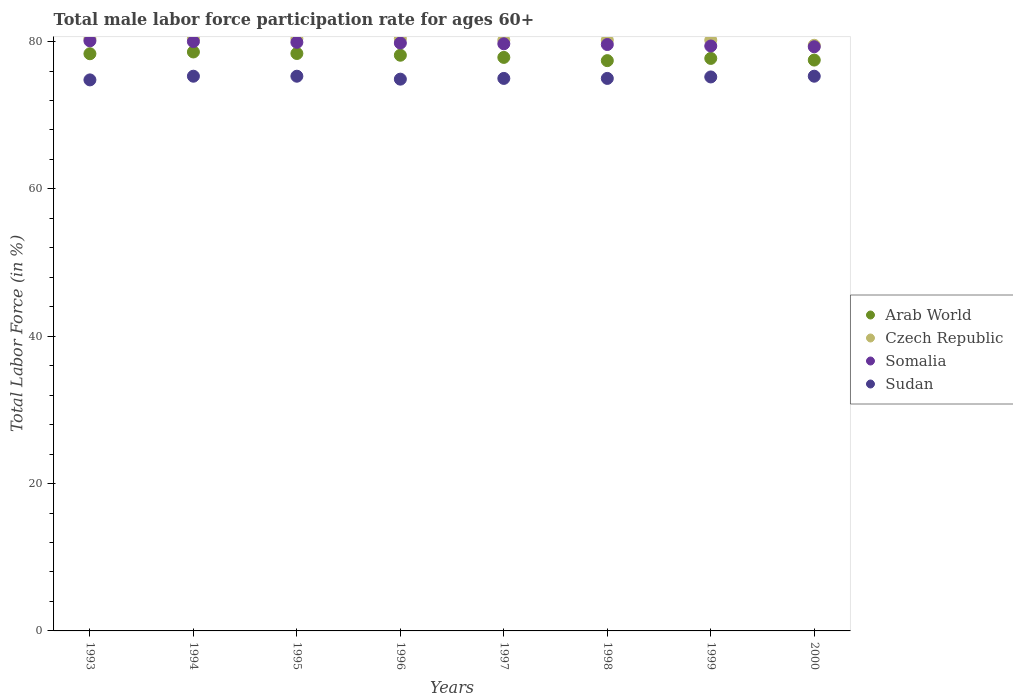How many different coloured dotlines are there?
Provide a short and direct response. 4. Is the number of dotlines equal to the number of legend labels?
Your answer should be very brief. Yes. What is the male labor force participation rate in Sudan in 2000?
Your answer should be compact. 75.3. Across all years, what is the maximum male labor force participation rate in Arab World?
Offer a terse response. 78.59. Across all years, what is the minimum male labor force participation rate in Arab World?
Provide a short and direct response. 77.41. In which year was the male labor force participation rate in Arab World maximum?
Keep it short and to the point. 1994. In which year was the male labor force participation rate in Sudan minimum?
Give a very brief answer. 1993. What is the total male labor force participation rate in Czech Republic in the graph?
Your response must be concise. 641.7. What is the difference between the male labor force participation rate in Czech Republic in 1994 and that in 1998?
Provide a short and direct response. 0.2. What is the difference between the male labor force participation rate in Somalia in 1994 and the male labor force participation rate in Czech Republic in 1996?
Your answer should be very brief. -0.4. What is the average male labor force participation rate in Czech Republic per year?
Provide a succinct answer. 80.21. In the year 1997, what is the difference between the male labor force participation rate in Czech Republic and male labor force participation rate in Somalia?
Your response must be concise. 0.5. What is the ratio of the male labor force participation rate in Sudan in 1993 to that in 1999?
Ensure brevity in your answer.  0.99. What is the difference between the highest and the lowest male labor force participation rate in Arab World?
Provide a short and direct response. 1.18. Is the sum of the male labor force participation rate in Czech Republic in 1994 and 1999 greater than the maximum male labor force participation rate in Arab World across all years?
Ensure brevity in your answer.  Yes. Is it the case that in every year, the sum of the male labor force participation rate in Somalia and male labor force participation rate in Sudan  is greater than the male labor force participation rate in Arab World?
Your answer should be very brief. Yes. Is the male labor force participation rate in Czech Republic strictly greater than the male labor force participation rate in Arab World over the years?
Offer a terse response. Yes. Is the male labor force participation rate in Arab World strictly less than the male labor force participation rate in Sudan over the years?
Keep it short and to the point. No. How many dotlines are there?
Give a very brief answer. 4. Where does the legend appear in the graph?
Your answer should be compact. Center right. What is the title of the graph?
Make the answer very short. Total male labor force participation rate for ages 60+. Does "India" appear as one of the legend labels in the graph?
Give a very brief answer. No. What is the label or title of the Y-axis?
Your answer should be very brief. Total Labor Force (in %). What is the Total Labor Force (in %) in Arab World in 1993?
Make the answer very short. 78.35. What is the Total Labor Force (in %) of Czech Republic in 1993?
Make the answer very short. 80.4. What is the Total Labor Force (in %) in Somalia in 1993?
Make the answer very short. 80.1. What is the Total Labor Force (in %) in Sudan in 1993?
Make the answer very short. 74.8. What is the Total Labor Force (in %) in Arab World in 1994?
Make the answer very short. 78.59. What is the Total Labor Force (in %) in Czech Republic in 1994?
Your answer should be very brief. 80.4. What is the Total Labor Force (in %) of Sudan in 1994?
Ensure brevity in your answer.  75.3. What is the Total Labor Force (in %) of Arab World in 1995?
Keep it short and to the point. 78.38. What is the Total Labor Force (in %) in Czech Republic in 1995?
Make the answer very short. 80.4. What is the Total Labor Force (in %) of Somalia in 1995?
Offer a very short reply. 79.9. What is the Total Labor Force (in %) of Sudan in 1995?
Ensure brevity in your answer.  75.3. What is the Total Labor Force (in %) in Arab World in 1996?
Make the answer very short. 78.15. What is the Total Labor Force (in %) of Czech Republic in 1996?
Provide a short and direct response. 80.4. What is the Total Labor Force (in %) in Somalia in 1996?
Your answer should be compact. 79.8. What is the Total Labor Force (in %) of Sudan in 1996?
Ensure brevity in your answer.  74.9. What is the Total Labor Force (in %) in Arab World in 1997?
Ensure brevity in your answer.  77.85. What is the Total Labor Force (in %) of Czech Republic in 1997?
Your answer should be compact. 80.2. What is the Total Labor Force (in %) of Somalia in 1997?
Your response must be concise. 79.7. What is the Total Labor Force (in %) of Sudan in 1997?
Your answer should be very brief. 75. What is the Total Labor Force (in %) in Arab World in 1998?
Ensure brevity in your answer.  77.41. What is the Total Labor Force (in %) of Czech Republic in 1998?
Offer a very short reply. 80.2. What is the Total Labor Force (in %) of Somalia in 1998?
Your answer should be very brief. 79.6. What is the Total Labor Force (in %) in Sudan in 1998?
Your answer should be compact. 75. What is the Total Labor Force (in %) of Arab World in 1999?
Give a very brief answer. 77.72. What is the Total Labor Force (in %) of Czech Republic in 1999?
Provide a short and direct response. 80.2. What is the Total Labor Force (in %) in Somalia in 1999?
Make the answer very short. 79.4. What is the Total Labor Force (in %) of Sudan in 1999?
Your answer should be compact. 75.2. What is the Total Labor Force (in %) in Arab World in 2000?
Make the answer very short. 77.49. What is the Total Labor Force (in %) of Czech Republic in 2000?
Offer a very short reply. 79.5. What is the Total Labor Force (in %) in Somalia in 2000?
Offer a very short reply. 79.3. What is the Total Labor Force (in %) in Sudan in 2000?
Your response must be concise. 75.3. Across all years, what is the maximum Total Labor Force (in %) in Arab World?
Offer a very short reply. 78.59. Across all years, what is the maximum Total Labor Force (in %) in Czech Republic?
Offer a terse response. 80.4. Across all years, what is the maximum Total Labor Force (in %) in Somalia?
Make the answer very short. 80.1. Across all years, what is the maximum Total Labor Force (in %) in Sudan?
Keep it short and to the point. 75.3. Across all years, what is the minimum Total Labor Force (in %) of Arab World?
Your answer should be compact. 77.41. Across all years, what is the minimum Total Labor Force (in %) of Czech Republic?
Provide a short and direct response. 79.5. Across all years, what is the minimum Total Labor Force (in %) in Somalia?
Your answer should be compact. 79.3. Across all years, what is the minimum Total Labor Force (in %) of Sudan?
Make the answer very short. 74.8. What is the total Total Labor Force (in %) of Arab World in the graph?
Give a very brief answer. 623.94. What is the total Total Labor Force (in %) in Czech Republic in the graph?
Provide a succinct answer. 641.7. What is the total Total Labor Force (in %) of Somalia in the graph?
Provide a short and direct response. 637.8. What is the total Total Labor Force (in %) of Sudan in the graph?
Keep it short and to the point. 600.8. What is the difference between the Total Labor Force (in %) of Arab World in 1993 and that in 1994?
Ensure brevity in your answer.  -0.24. What is the difference between the Total Labor Force (in %) of Czech Republic in 1993 and that in 1994?
Offer a terse response. 0. What is the difference between the Total Labor Force (in %) in Somalia in 1993 and that in 1994?
Keep it short and to the point. 0.1. What is the difference between the Total Labor Force (in %) in Arab World in 1993 and that in 1995?
Provide a succinct answer. -0.03. What is the difference between the Total Labor Force (in %) in Czech Republic in 1993 and that in 1995?
Ensure brevity in your answer.  0. What is the difference between the Total Labor Force (in %) of Arab World in 1993 and that in 1996?
Give a very brief answer. 0.2. What is the difference between the Total Labor Force (in %) in Somalia in 1993 and that in 1996?
Provide a short and direct response. 0.3. What is the difference between the Total Labor Force (in %) in Sudan in 1993 and that in 1996?
Your answer should be compact. -0.1. What is the difference between the Total Labor Force (in %) of Arab World in 1993 and that in 1997?
Give a very brief answer. 0.5. What is the difference between the Total Labor Force (in %) in Sudan in 1993 and that in 1997?
Your answer should be compact. -0.2. What is the difference between the Total Labor Force (in %) in Arab World in 1993 and that in 1998?
Keep it short and to the point. 0.94. What is the difference between the Total Labor Force (in %) in Somalia in 1993 and that in 1998?
Your answer should be compact. 0.5. What is the difference between the Total Labor Force (in %) in Arab World in 1993 and that in 1999?
Your response must be concise. 0.63. What is the difference between the Total Labor Force (in %) in Czech Republic in 1993 and that in 1999?
Your answer should be very brief. 0.2. What is the difference between the Total Labor Force (in %) of Sudan in 1993 and that in 1999?
Ensure brevity in your answer.  -0.4. What is the difference between the Total Labor Force (in %) in Arab World in 1993 and that in 2000?
Ensure brevity in your answer.  0.86. What is the difference between the Total Labor Force (in %) of Czech Republic in 1993 and that in 2000?
Offer a terse response. 0.9. What is the difference between the Total Labor Force (in %) in Arab World in 1994 and that in 1995?
Keep it short and to the point. 0.21. What is the difference between the Total Labor Force (in %) in Sudan in 1994 and that in 1995?
Make the answer very short. 0. What is the difference between the Total Labor Force (in %) of Arab World in 1994 and that in 1996?
Give a very brief answer. 0.44. What is the difference between the Total Labor Force (in %) in Czech Republic in 1994 and that in 1996?
Your answer should be compact. 0. What is the difference between the Total Labor Force (in %) in Arab World in 1994 and that in 1997?
Ensure brevity in your answer.  0.74. What is the difference between the Total Labor Force (in %) of Czech Republic in 1994 and that in 1997?
Give a very brief answer. 0.2. What is the difference between the Total Labor Force (in %) in Somalia in 1994 and that in 1997?
Make the answer very short. 0.3. What is the difference between the Total Labor Force (in %) in Sudan in 1994 and that in 1997?
Your response must be concise. 0.3. What is the difference between the Total Labor Force (in %) in Arab World in 1994 and that in 1998?
Offer a very short reply. 1.18. What is the difference between the Total Labor Force (in %) in Sudan in 1994 and that in 1999?
Offer a terse response. 0.1. What is the difference between the Total Labor Force (in %) in Arab World in 1994 and that in 2000?
Your response must be concise. 1.1. What is the difference between the Total Labor Force (in %) in Somalia in 1994 and that in 2000?
Your answer should be very brief. 0.7. What is the difference between the Total Labor Force (in %) in Arab World in 1995 and that in 1996?
Your answer should be compact. 0.24. What is the difference between the Total Labor Force (in %) of Czech Republic in 1995 and that in 1996?
Provide a succinct answer. 0. What is the difference between the Total Labor Force (in %) of Somalia in 1995 and that in 1996?
Offer a terse response. 0.1. What is the difference between the Total Labor Force (in %) in Arab World in 1995 and that in 1997?
Provide a short and direct response. 0.53. What is the difference between the Total Labor Force (in %) in Czech Republic in 1995 and that in 1997?
Offer a terse response. 0.2. What is the difference between the Total Labor Force (in %) of Sudan in 1995 and that in 1997?
Your answer should be very brief. 0.3. What is the difference between the Total Labor Force (in %) of Arab World in 1995 and that in 1998?
Your answer should be very brief. 0.97. What is the difference between the Total Labor Force (in %) in Arab World in 1995 and that in 1999?
Provide a short and direct response. 0.67. What is the difference between the Total Labor Force (in %) in Arab World in 1995 and that in 2000?
Keep it short and to the point. 0.89. What is the difference between the Total Labor Force (in %) of Somalia in 1995 and that in 2000?
Give a very brief answer. 0.6. What is the difference between the Total Labor Force (in %) of Arab World in 1996 and that in 1997?
Offer a terse response. 0.3. What is the difference between the Total Labor Force (in %) in Czech Republic in 1996 and that in 1997?
Your answer should be very brief. 0.2. What is the difference between the Total Labor Force (in %) of Somalia in 1996 and that in 1997?
Your answer should be compact. 0.1. What is the difference between the Total Labor Force (in %) in Sudan in 1996 and that in 1997?
Keep it short and to the point. -0.1. What is the difference between the Total Labor Force (in %) in Arab World in 1996 and that in 1998?
Your answer should be compact. 0.73. What is the difference between the Total Labor Force (in %) in Czech Republic in 1996 and that in 1998?
Ensure brevity in your answer.  0.2. What is the difference between the Total Labor Force (in %) in Sudan in 1996 and that in 1998?
Your response must be concise. -0.1. What is the difference between the Total Labor Force (in %) of Arab World in 1996 and that in 1999?
Keep it short and to the point. 0.43. What is the difference between the Total Labor Force (in %) of Somalia in 1996 and that in 1999?
Make the answer very short. 0.4. What is the difference between the Total Labor Force (in %) of Sudan in 1996 and that in 1999?
Give a very brief answer. -0.3. What is the difference between the Total Labor Force (in %) in Arab World in 1996 and that in 2000?
Make the answer very short. 0.66. What is the difference between the Total Labor Force (in %) in Arab World in 1997 and that in 1998?
Your response must be concise. 0.44. What is the difference between the Total Labor Force (in %) in Somalia in 1997 and that in 1998?
Provide a short and direct response. 0.1. What is the difference between the Total Labor Force (in %) in Sudan in 1997 and that in 1998?
Provide a succinct answer. 0. What is the difference between the Total Labor Force (in %) in Arab World in 1997 and that in 1999?
Ensure brevity in your answer.  0.14. What is the difference between the Total Labor Force (in %) in Somalia in 1997 and that in 1999?
Offer a terse response. 0.3. What is the difference between the Total Labor Force (in %) in Sudan in 1997 and that in 1999?
Give a very brief answer. -0.2. What is the difference between the Total Labor Force (in %) of Arab World in 1997 and that in 2000?
Your answer should be very brief. 0.36. What is the difference between the Total Labor Force (in %) of Czech Republic in 1997 and that in 2000?
Your answer should be very brief. 0.7. What is the difference between the Total Labor Force (in %) in Sudan in 1997 and that in 2000?
Your response must be concise. -0.3. What is the difference between the Total Labor Force (in %) of Arab World in 1998 and that in 1999?
Provide a succinct answer. -0.3. What is the difference between the Total Labor Force (in %) of Czech Republic in 1998 and that in 1999?
Offer a terse response. 0. What is the difference between the Total Labor Force (in %) in Arab World in 1998 and that in 2000?
Your answer should be very brief. -0.08. What is the difference between the Total Labor Force (in %) of Somalia in 1998 and that in 2000?
Ensure brevity in your answer.  0.3. What is the difference between the Total Labor Force (in %) of Sudan in 1998 and that in 2000?
Give a very brief answer. -0.3. What is the difference between the Total Labor Force (in %) in Arab World in 1999 and that in 2000?
Provide a succinct answer. 0.22. What is the difference between the Total Labor Force (in %) of Czech Republic in 1999 and that in 2000?
Provide a short and direct response. 0.7. What is the difference between the Total Labor Force (in %) in Somalia in 1999 and that in 2000?
Make the answer very short. 0.1. What is the difference between the Total Labor Force (in %) in Sudan in 1999 and that in 2000?
Offer a terse response. -0.1. What is the difference between the Total Labor Force (in %) of Arab World in 1993 and the Total Labor Force (in %) of Czech Republic in 1994?
Keep it short and to the point. -2.05. What is the difference between the Total Labor Force (in %) of Arab World in 1993 and the Total Labor Force (in %) of Somalia in 1994?
Provide a succinct answer. -1.65. What is the difference between the Total Labor Force (in %) of Arab World in 1993 and the Total Labor Force (in %) of Sudan in 1994?
Keep it short and to the point. 3.05. What is the difference between the Total Labor Force (in %) in Czech Republic in 1993 and the Total Labor Force (in %) in Somalia in 1994?
Keep it short and to the point. 0.4. What is the difference between the Total Labor Force (in %) in Arab World in 1993 and the Total Labor Force (in %) in Czech Republic in 1995?
Keep it short and to the point. -2.05. What is the difference between the Total Labor Force (in %) in Arab World in 1993 and the Total Labor Force (in %) in Somalia in 1995?
Offer a very short reply. -1.55. What is the difference between the Total Labor Force (in %) in Arab World in 1993 and the Total Labor Force (in %) in Sudan in 1995?
Ensure brevity in your answer.  3.05. What is the difference between the Total Labor Force (in %) of Arab World in 1993 and the Total Labor Force (in %) of Czech Republic in 1996?
Offer a very short reply. -2.05. What is the difference between the Total Labor Force (in %) of Arab World in 1993 and the Total Labor Force (in %) of Somalia in 1996?
Offer a very short reply. -1.45. What is the difference between the Total Labor Force (in %) of Arab World in 1993 and the Total Labor Force (in %) of Sudan in 1996?
Ensure brevity in your answer.  3.45. What is the difference between the Total Labor Force (in %) in Czech Republic in 1993 and the Total Labor Force (in %) in Somalia in 1996?
Your response must be concise. 0.6. What is the difference between the Total Labor Force (in %) in Somalia in 1993 and the Total Labor Force (in %) in Sudan in 1996?
Keep it short and to the point. 5.2. What is the difference between the Total Labor Force (in %) in Arab World in 1993 and the Total Labor Force (in %) in Czech Republic in 1997?
Offer a very short reply. -1.85. What is the difference between the Total Labor Force (in %) of Arab World in 1993 and the Total Labor Force (in %) of Somalia in 1997?
Provide a succinct answer. -1.35. What is the difference between the Total Labor Force (in %) of Arab World in 1993 and the Total Labor Force (in %) of Sudan in 1997?
Keep it short and to the point. 3.35. What is the difference between the Total Labor Force (in %) in Somalia in 1993 and the Total Labor Force (in %) in Sudan in 1997?
Offer a terse response. 5.1. What is the difference between the Total Labor Force (in %) of Arab World in 1993 and the Total Labor Force (in %) of Czech Republic in 1998?
Provide a succinct answer. -1.85. What is the difference between the Total Labor Force (in %) of Arab World in 1993 and the Total Labor Force (in %) of Somalia in 1998?
Provide a short and direct response. -1.25. What is the difference between the Total Labor Force (in %) of Arab World in 1993 and the Total Labor Force (in %) of Sudan in 1998?
Keep it short and to the point. 3.35. What is the difference between the Total Labor Force (in %) in Czech Republic in 1993 and the Total Labor Force (in %) in Somalia in 1998?
Keep it short and to the point. 0.8. What is the difference between the Total Labor Force (in %) of Somalia in 1993 and the Total Labor Force (in %) of Sudan in 1998?
Provide a succinct answer. 5.1. What is the difference between the Total Labor Force (in %) in Arab World in 1993 and the Total Labor Force (in %) in Czech Republic in 1999?
Keep it short and to the point. -1.85. What is the difference between the Total Labor Force (in %) of Arab World in 1993 and the Total Labor Force (in %) of Somalia in 1999?
Provide a short and direct response. -1.05. What is the difference between the Total Labor Force (in %) in Arab World in 1993 and the Total Labor Force (in %) in Sudan in 1999?
Provide a succinct answer. 3.15. What is the difference between the Total Labor Force (in %) in Czech Republic in 1993 and the Total Labor Force (in %) in Sudan in 1999?
Offer a very short reply. 5.2. What is the difference between the Total Labor Force (in %) of Arab World in 1993 and the Total Labor Force (in %) of Czech Republic in 2000?
Ensure brevity in your answer.  -1.15. What is the difference between the Total Labor Force (in %) in Arab World in 1993 and the Total Labor Force (in %) in Somalia in 2000?
Provide a succinct answer. -0.95. What is the difference between the Total Labor Force (in %) of Arab World in 1993 and the Total Labor Force (in %) of Sudan in 2000?
Your response must be concise. 3.05. What is the difference between the Total Labor Force (in %) of Somalia in 1993 and the Total Labor Force (in %) of Sudan in 2000?
Provide a succinct answer. 4.8. What is the difference between the Total Labor Force (in %) of Arab World in 1994 and the Total Labor Force (in %) of Czech Republic in 1995?
Ensure brevity in your answer.  -1.81. What is the difference between the Total Labor Force (in %) of Arab World in 1994 and the Total Labor Force (in %) of Somalia in 1995?
Provide a succinct answer. -1.31. What is the difference between the Total Labor Force (in %) of Arab World in 1994 and the Total Labor Force (in %) of Sudan in 1995?
Make the answer very short. 3.29. What is the difference between the Total Labor Force (in %) in Czech Republic in 1994 and the Total Labor Force (in %) in Somalia in 1995?
Keep it short and to the point. 0.5. What is the difference between the Total Labor Force (in %) in Czech Republic in 1994 and the Total Labor Force (in %) in Sudan in 1995?
Make the answer very short. 5.1. What is the difference between the Total Labor Force (in %) in Somalia in 1994 and the Total Labor Force (in %) in Sudan in 1995?
Offer a terse response. 4.7. What is the difference between the Total Labor Force (in %) in Arab World in 1994 and the Total Labor Force (in %) in Czech Republic in 1996?
Make the answer very short. -1.81. What is the difference between the Total Labor Force (in %) in Arab World in 1994 and the Total Labor Force (in %) in Somalia in 1996?
Offer a very short reply. -1.21. What is the difference between the Total Labor Force (in %) of Arab World in 1994 and the Total Labor Force (in %) of Sudan in 1996?
Keep it short and to the point. 3.69. What is the difference between the Total Labor Force (in %) of Czech Republic in 1994 and the Total Labor Force (in %) of Somalia in 1996?
Provide a succinct answer. 0.6. What is the difference between the Total Labor Force (in %) in Somalia in 1994 and the Total Labor Force (in %) in Sudan in 1996?
Give a very brief answer. 5.1. What is the difference between the Total Labor Force (in %) of Arab World in 1994 and the Total Labor Force (in %) of Czech Republic in 1997?
Provide a short and direct response. -1.61. What is the difference between the Total Labor Force (in %) of Arab World in 1994 and the Total Labor Force (in %) of Somalia in 1997?
Ensure brevity in your answer.  -1.11. What is the difference between the Total Labor Force (in %) of Arab World in 1994 and the Total Labor Force (in %) of Sudan in 1997?
Your answer should be compact. 3.59. What is the difference between the Total Labor Force (in %) of Czech Republic in 1994 and the Total Labor Force (in %) of Sudan in 1997?
Make the answer very short. 5.4. What is the difference between the Total Labor Force (in %) in Somalia in 1994 and the Total Labor Force (in %) in Sudan in 1997?
Ensure brevity in your answer.  5. What is the difference between the Total Labor Force (in %) in Arab World in 1994 and the Total Labor Force (in %) in Czech Republic in 1998?
Offer a terse response. -1.61. What is the difference between the Total Labor Force (in %) in Arab World in 1994 and the Total Labor Force (in %) in Somalia in 1998?
Offer a very short reply. -1.01. What is the difference between the Total Labor Force (in %) of Arab World in 1994 and the Total Labor Force (in %) of Sudan in 1998?
Offer a very short reply. 3.59. What is the difference between the Total Labor Force (in %) in Czech Republic in 1994 and the Total Labor Force (in %) in Somalia in 1998?
Provide a short and direct response. 0.8. What is the difference between the Total Labor Force (in %) in Czech Republic in 1994 and the Total Labor Force (in %) in Sudan in 1998?
Ensure brevity in your answer.  5.4. What is the difference between the Total Labor Force (in %) in Arab World in 1994 and the Total Labor Force (in %) in Czech Republic in 1999?
Your answer should be very brief. -1.61. What is the difference between the Total Labor Force (in %) of Arab World in 1994 and the Total Labor Force (in %) of Somalia in 1999?
Your answer should be compact. -0.81. What is the difference between the Total Labor Force (in %) in Arab World in 1994 and the Total Labor Force (in %) in Sudan in 1999?
Make the answer very short. 3.39. What is the difference between the Total Labor Force (in %) in Arab World in 1994 and the Total Labor Force (in %) in Czech Republic in 2000?
Provide a succinct answer. -0.91. What is the difference between the Total Labor Force (in %) in Arab World in 1994 and the Total Labor Force (in %) in Somalia in 2000?
Provide a succinct answer. -0.71. What is the difference between the Total Labor Force (in %) of Arab World in 1994 and the Total Labor Force (in %) of Sudan in 2000?
Give a very brief answer. 3.29. What is the difference between the Total Labor Force (in %) in Czech Republic in 1994 and the Total Labor Force (in %) in Somalia in 2000?
Keep it short and to the point. 1.1. What is the difference between the Total Labor Force (in %) in Czech Republic in 1994 and the Total Labor Force (in %) in Sudan in 2000?
Give a very brief answer. 5.1. What is the difference between the Total Labor Force (in %) of Arab World in 1995 and the Total Labor Force (in %) of Czech Republic in 1996?
Give a very brief answer. -2.02. What is the difference between the Total Labor Force (in %) of Arab World in 1995 and the Total Labor Force (in %) of Somalia in 1996?
Provide a short and direct response. -1.42. What is the difference between the Total Labor Force (in %) in Arab World in 1995 and the Total Labor Force (in %) in Sudan in 1996?
Provide a succinct answer. 3.48. What is the difference between the Total Labor Force (in %) of Czech Republic in 1995 and the Total Labor Force (in %) of Sudan in 1996?
Give a very brief answer. 5.5. What is the difference between the Total Labor Force (in %) of Somalia in 1995 and the Total Labor Force (in %) of Sudan in 1996?
Ensure brevity in your answer.  5. What is the difference between the Total Labor Force (in %) of Arab World in 1995 and the Total Labor Force (in %) of Czech Republic in 1997?
Provide a short and direct response. -1.82. What is the difference between the Total Labor Force (in %) in Arab World in 1995 and the Total Labor Force (in %) in Somalia in 1997?
Your answer should be very brief. -1.32. What is the difference between the Total Labor Force (in %) in Arab World in 1995 and the Total Labor Force (in %) in Sudan in 1997?
Provide a succinct answer. 3.38. What is the difference between the Total Labor Force (in %) in Somalia in 1995 and the Total Labor Force (in %) in Sudan in 1997?
Your answer should be compact. 4.9. What is the difference between the Total Labor Force (in %) of Arab World in 1995 and the Total Labor Force (in %) of Czech Republic in 1998?
Give a very brief answer. -1.82. What is the difference between the Total Labor Force (in %) of Arab World in 1995 and the Total Labor Force (in %) of Somalia in 1998?
Your response must be concise. -1.22. What is the difference between the Total Labor Force (in %) in Arab World in 1995 and the Total Labor Force (in %) in Sudan in 1998?
Your answer should be very brief. 3.38. What is the difference between the Total Labor Force (in %) in Czech Republic in 1995 and the Total Labor Force (in %) in Somalia in 1998?
Your response must be concise. 0.8. What is the difference between the Total Labor Force (in %) in Czech Republic in 1995 and the Total Labor Force (in %) in Sudan in 1998?
Ensure brevity in your answer.  5.4. What is the difference between the Total Labor Force (in %) in Arab World in 1995 and the Total Labor Force (in %) in Czech Republic in 1999?
Give a very brief answer. -1.82. What is the difference between the Total Labor Force (in %) in Arab World in 1995 and the Total Labor Force (in %) in Somalia in 1999?
Offer a very short reply. -1.02. What is the difference between the Total Labor Force (in %) in Arab World in 1995 and the Total Labor Force (in %) in Sudan in 1999?
Ensure brevity in your answer.  3.18. What is the difference between the Total Labor Force (in %) in Somalia in 1995 and the Total Labor Force (in %) in Sudan in 1999?
Keep it short and to the point. 4.7. What is the difference between the Total Labor Force (in %) in Arab World in 1995 and the Total Labor Force (in %) in Czech Republic in 2000?
Ensure brevity in your answer.  -1.12. What is the difference between the Total Labor Force (in %) in Arab World in 1995 and the Total Labor Force (in %) in Somalia in 2000?
Your answer should be compact. -0.92. What is the difference between the Total Labor Force (in %) of Arab World in 1995 and the Total Labor Force (in %) of Sudan in 2000?
Offer a very short reply. 3.08. What is the difference between the Total Labor Force (in %) in Arab World in 1996 and the Total Labor Force (in %) in Czech Republic in 1997?
Provide a short and direct response. -2.05. What is the difference between the Total Labor Force (in %) of Arab World in 1996 and the Total Labor Force (in %) of Somalia in 1997?
Ensure brevity in your answer.  -1.55. What is the difference between the Total Labor Force (in %) of Arab World in 1996 and the Total Labor Force (in %) of Sudan in 1997?
Your response must be concise. 3.15. What is the difference between the Total Labor Force (in %) of Czech Republic in 1996 and the Total Labor Force (in %) of Somalia in 1997?
Offer a very short reply. 0.7. What is the difference between the Total Labor Force (in %) in Czech Republic in 1996 and the Total Labor Force (in %) in Sudan in 1997?
Provide a succinct answer. 5.4. What is the difference between the Total Labor Force (in %) of Somalia in 1996 and the Total Labor Force (in %) of Sudan in 1997?
Offer a very short reply. 4.8. What is the difference between the Total Labor Force (in %) of Arab World in 1996 and the Total Labor Force (in %) of Czech Republic in 1998?
Make the answer very short. -2.05. What is the difference between the Total Labor Force (in %) in Arab World in 1996 and the Total Labor Force (in %) in Somalia in 1998?
Offer a very short reply. -1.45. What is the difference between the Total Labor Force (in %) of Arab World in 1996 and the Total Labor Force (in %) of Sudan in 1998?
Your response must be concise. 3.15. What is the difference between the Total Labor Force (in %) in Somalia in 1996 and the Total Labor Force (in %) in Sudan in 1998?
Your answer should be very brief. 4.8. What is the difference between the Total Labor Force (in %) of Arab World in 1996 and the Total Labor Force (in %) of Czech Republic in 1999?
Make the answer very short. -2.05. What is the difference between the Total Labor Force (in %) in Arab World in 1996 and the Total Labor Force (in %) in Somalia in 1999?
Your answer should be compact. -1.25. What is the difference between the Total Labor Force (in %) in Arab World in 1996 and the Total Labor Force (in %) in Sudan in 1999?
Provide a succinct answer. 2.95. What is the difference between the Total Labor Force (in %) of Czech Republic in 1996 and the Total Labor Force (in %) of Sudan in 1999?
Provide a short and direct response. 5.2. What is the difference between the Total Labor Force (in %) in Arab World in 1996 and the Total Labor Force (in %) in Czech Republic in 2000?
Keep it short and to the point. -1.35. What is the difference between the Total Labor Force (in %) in Arab World in 1996 and the Total Labor Force (in %) in Somalia in 2000?
Offer a terse response. -1.15. What is the difference between the Total Labor Force (in %) in Arab World in 1996 and the Total Labor Force (in %) in Sudan in 2000?
Ensure brevity in your answer.  2.85. What is the difference between the Total Labor Force (in %) in Czech Republic in 1996 and the Total Labor Force (in %) in Somalia in 2000?
Offer a terse response. 1.1. What is the difference between the Total Labor Force (in %) of Somalia in 1996 and the Total Labor Force (in %) of Sudan in 2000?
Ensure brevity in your answer.  4.5. What is the difference between the Total Labor Force (in %) of Arab World in 1997 and the Total Labor Force (in %) of Czech Republic in 1998?
Keep it short and to the point. -2.35. What is the difference between the Total Labor Force (in %) in Arab World in 1997 and the Total Labor Force (in %) in Somalia in 1998?
Your answer should be very brief. -1.75. What is the difference between the Total Labor Force (in %) in Arab World in 1997 and the Total Labor Force (in %) in Sudan in 1998?
Ensure brevity in your answer.  2.85. What is the difference between the Total Labor Force (in %) of Czech Republic in 1997 and the Total Labor Force (in %) of Sudan in 1998?
Make the answer very short. 5.2. What is the difference between the Total Labor Force (in %) of Arab World in 1997 and the Total Labor Force (in %) of Czech Republic in 1999?
Provide a short and direct response. -2.35. What is the difference between the Total Labor Force (in %) of Arab World in 1997 and the Total Labor Force (in %) of Somalia in 1999?
Provide a succinct answer. -1.55. What is the difference between the Total Labor Force (in %) of Arab World in 1997 and the Total Labor Force (in %) of Sudan in 1999?
Offer a terse response. 2.65. What is the difference between the Total Labor Force (in %) in Czech Republic in 1997 and the Total Labor Force (in %) in Somalia in 1999?
Offer a very short reply. 0.8. What is the difference between the Total Labor Force (in %) of Czech Republic in 1997 and the Total Labor Force (in %) of Sudan in 1999?
Offer a terse response. 5. What is the difference between the Total Labor Force (in %) in Somalia in 1997 and the Total Labor Force (in %) in Sudan in 1999?
Give a very brief answer. 4.5. What is the difference between the Total Labor Force (in %) in Arab World in 1997 and the Total Labor Force (in %) in Czech Republic in 2000?
Give a very brief answer. -1.65. What is the difference between the Total Labor Force (in %) in Arab World in 1997 and the Total Labor Force (in %) in Somalia in 2000?
Ensure brevity in your answer.  -1.45. What is the difference between the Total Labor Force (in %) in Arab World in 1997 and the Total Labor Force (in %) in Sudan in 2000?
Provide a succinct answer. 2.55. What is the difference between the Total Labor Force (in %) in Czech Republic in 1997 and the Total Labor Force (in %) in Sudan in 2000?
Keep it short and to the point. 4.9. What is the difference between the Total Labor Force (in %) in Arab World in 1998 and the Total Labor Force (in %) in Czech Republic in 1999?
Offer a very short reply. -2.79. What is the difference between the Total Labor Force (in %) of Arab World in 1998 and the Total Labor Force (in %) of Somalia in 1999?
Make the answer very short. -1.99. What is the difference between the Total Labor Force (in %) in Arab World in 1998 and the Total Labor Force (in %) in Sudan in 1999?
Offer a terse response. 2.21. What is the difference between the Total Labor Force (in %) of Czech Republic in 1998 and the Total Labor Force (in %) of Somalia in 1999?
Your answer should be very brief. 0.8. What is the difference between the Total Labor Force (in %) in Czech Republic in 1998 and the Total Labor Force (in %) in Sudan in 1999?
Provide a short and direct response. 5. What is the difference between the Total Labor Force (in %) in Somalia in 1998 and the Total Labor Force (in %) in Sudan in 1999?
Your answer should be compact. 4.4. What is the difference between the Total Labor Force (in %) in Arab World in 1998 and the Total Labor Force (in %) in Czech Republic in 2000?
Offer a very short reply. -2.09. What is the difference between the Total Labor Force (in %) in Arab World in 1998 and the Total Labor Force (in %) in Somalia in 2000?
Offer a terse response. -1.89. What is the difference between the Total Labor Force (in %) in Arab World in 1998 and the Total Labor Force (in %) in Sudan in 2000?
Your response must be concise. 2.11. What is the difference between the Total Labor Force (in %) in Czech Republic in 1998 and the Total Labor Force (in %) in Somalia in 2000?
Provide a short and direct response. 0.9. What is the difference between the Total Labor Force (in %) of Arab World in 1999 and the Total Labor Force (in %) of Czech Republic in 2000?
Provide a succinct answer. -1.78. What is the difference between the Total Labor Force (in %) in Arab World in 1999 and the Total Labor Force (in %) in Somalia in 2000?
Ensure brevity in your answer.  -1.58. What is the difference between the Total Labor Force (in %) of Arab World in 1999 and the Total Labor Force (in %) of Sudan in 2000?
Provide a succinct answer. 2.42. What is the difference between the Total Labor Force (in %) in Czech Republic in 1999 and the Total Labor Force (in %) in Sudan in 2000?
Make the answer very short. 4.9. What is the difference between the Total Labor Force (in %) of Somalia in 1999 and the Total Labor Force (in %) of Sudan in 2000?
Offer a terse response. 4.1. What is the average Total Labor Force (in %) in Arab World per year?
Make the answer very short. 77.99. What is the average Total Labor Force (in %) of Czech Republic per year?
Ensure brevity in your answer.  80.21. What is the average Total Labor Force (in %) in Somalia per year?
Your response must be concise. 79.72. What is the average Total Labor Force (in %) in Sudan per year?
Make the answer very short. 75.1. In the year 1993, what is the difference between the Total Labor Force (in %) of Arab World and Total Labor Force (in %) of Czech Republic?
Offer a terse response. -2.05. In the year 1993, what is the difference between the Total Labor Force (in %) in Arab World and Total Labor Force (in %) in Somalia?
Your response must be concise. -1.75. In the year 1993, what is the difference between the Total Labor Force (in %) in Arab World and Total Labor Force (in %) in Sudan?
Keep it short and to the point. 3.55. In the year 1993, what is the difference between the Total Labor Force (in %) in Czech Republic and Total Labor Force (in %) in Somalia?
Give a very brief answer. 0.3. In the year 1993, what is the difference between the Total Labor Force (in %) of Somalia and Total Labor Force (in %) of Sudan?
Your response must be concise. 5.3. In the year 1994, what is the difference between the Total Labor Force (in %) of Arab World and Total Labor Force (in %) of Czech Republic?
Make the answer very short. -1.81. In the year 1994, what is the difference between the Total Labor Force (in %) in Arab World and Total Labor Force (in %) in Somalia?
Offer a very short reply. -1.41. In the year 1994, what is the difference between the Total Labor Force (in %) in Arab World and Total Labor Force (in %) in Sudan?
Keep it short and to the point. 3.29. In the year 1994, what is the difference between the Total Labor Force (in %) in Czech Republic and Total Labor Force (in %) in Somalia?
Provide a short and direct response. 0.4. In the year 1994, what is the difference between the Total Labor Force (in %) in Czech Republic and Total Labor Force (in %) in Sudan?
Your response must be concise. 5.1. In the year 1994, what is the difference between the Total Labor Force (in %) of Somalia and Total Labor Force (in %) of Sudan?
Provide a succinct answer. 4.7. In the year 1995, what is the difference between the Total Labor Force (in %) in Arab World and Total Labor Force (in %) in Czech Republic?
Your response must be concise. -2.02. In the year 1995, what is the difference between the Total Labor Force (in %) in Arab World and Total Labor Force (in %) in Somalia?
Your answer should be very brief. -1.52. In the year 1995, what is the difference between the Total Labor Force (in %) of Arab World and Total Labor Force (in %) of Sudan?
Provide a short and direct response. 3.08. In the year 1995, what is the difference between the Total Labor Force (in %) in Czech Republic and Total Labor Force (in %) in Sudan?
Keep it short and to the point. 5.1. In the year 1996, what is the difference between the Total Labor Force (in %) of Arab World and Total Labor Force (in %) of Czech Republic?
Offer a very short reply. -2.25. In the year 1996, what is the difference between the Total Labor Force (in %) of Arab World and Total Labor Force (in %) of Somalia?
Offer a terse response. -1.65. In the year 1996, what is the difference between the Total Labor Force (in %) in Arab World and Total Labor Force (in %) in Sudan?
Your answer should be very brief. 3.25. In the year 1996, what is the difference between the Total Labor Force (in %) in Czech Republic and Total Labor Force (in %) in Somalia?
Give a very brief answer. 0.6. In the year 1997, what is the difference between the Total Labor Force (in %) of Arab World and Total Labor Force (in %) of Czech Republic?
Offer a very short reply. -2.35. In the year 1997, what is the difference between the Total Labor Force (in %) of Arab World and Total Labor Force (in %) of Somalia?
Keep it short and to the point. -1.85. In the year 1997, what is the difference between the Total Labor Force (in %) of Arab World and Total Labor Force (in %) of Sudan?
Your answer should be compact. 2.85. In the year 1997, what is the difference between the Total Labor Force (in %) in Czech Republic and Total Labor Force (in %) in Sudan?
Give a very brief answer. 5.2. In the year 1998, what is the difference between the Total Labor Force (in %) of Arab World and Total Labor Force (in %) of Czech Republic?
Your answer should be very brief. -2.79. In the year 1998, what is the difference between the Total Labor Force (in %) in Arab World and Total Labor Force (in %) in Somalia?
Provide a short and direct response. -2.19. In the year 1998, what is the difference between the Total Labor Force (in %) in Arab World and Total Labor Force (in %) in Sudan?
Offer a very short reply. 2.41. In the year 1999, what is the difference between the Total Labor Force (in %) in Arab World and Total Labor Force (in %) in Czech Republic?
Offer a very short reply. -2.48. In the year 1999, what is the difference between the Total Labor Force (in %) in Arab World and Total Labor Force (in %) in Somalia?
Make the answer very short. -1.68. In the year 1999, what is the difference between the Total Labor Force (in %) of Arab World and Total Labor Force (in %) of Sudan?
Keep it short and to the point. 2.52. In the year 2000, what is the difference between the Total Labor Force (in %) in Arab World and Total Labor Force (in %) in Czech Republic?
Your response must be concise. -2.01. In the year 2000, what is the difference between the Total Labor Force (in %) of Arab World and Total Labor Force (in %) of Somalia?
Keep it short and to the point. -1.81. In the year 2000, what is the difference between the Total Labor Force (in %) of Arab World and Total Labor Force (in %) of Sudan?
Provide a short and direct response. 2.19. What is the ratio of the Total Labor Force (in %) in Somalia in 1993 to that in 1994?
Make the answer very short. 1. What is the ratio of the Total Labor Force (in %) of Czech Republic in 1993 to that in 1995?
Provide a short and direct response. 1. What is the ratio of the Total Labor Force (in %) in Somalia in 1993 to that in 1995?
Your answer should be compact. 1. What is the ratio of the Total Labor Force (in %) in Sudan in 1993 to that in 1995?
Ensure brevity in your answer.  0.99. What is the ratio of the Total Labor Force (in %) of Sudan in 1993 to that in 1996?
Offer a very short reply. 1. What is the ratio of the Total Labor Force (in %) in Arab World in 1993 to that in 1997?
Your answer should be very brief. 1.01. What is the ratio of the Total Labor Force (in %) of Sudan in 1993 to that in 1997?
Provide a short and direct response. 1. What is the ratio of the Total Labor Force (in %) of Arab World in 1993 to that in 1998?
Make the answer very short. 1.01. What is the ratio of the Total Labor Force (in %) in Czech Republic in 1993 to that in 1998?
Provide a succinct answer. 1. What is the ratio of the Total Labor Force (in %) of Czech Republic in 1993 to that in 1999?
Provide a succinct answer. 1. What is the ratio of the Total Labor Force (in %) in Somalia in 1993 to that in 1999?
Keep it short and to the point. 1.01. What is the ratio of the Total Labor Force (in %) in Sudan in 1993 to that in 1999?
Provide a succinct answer. 0.99. What is the ratio of the Total Labor Force (in %) of Arab World in 1993 to that in 2000?
Provide a succinct answer. 1.01. What is the ratio of the Total Labor Force (in %) of Czech Republic in 1993 to that in 2000?
Make the answer very short. 1.01. What is the ratio of the Total Labor Force (in %) of Somalia in 1993 to that in 2000?
Keep it short and to the point. 1.01. What is the ratio of the Total Labor Force (in %) in Sudan in 1993 to that in 2000?
Your answer should be very brief. 0.99. What is the ratio of the Total Labor Force (in %) in Arab World in 1994 to that in 1995?
Provide a short and direct response. 1. What is the ratio of the Total Labor Force (in %) of Czech Republic in 1994 to that in 1995?
Provide a short and direct response. 1. What is the ratio of the Total Labor Force (in %) in Czech Republic in 1994 to that in 1996?
Provide a succinct answer. 1. What is the ratio of the Total Labor Force (in %) of Somalia in 1994 to that in 1996?
Provide a short and direct response. 1. What is the ratio of the Total Labor Force (in %) in Sudan in 1994 to that in 1996?
Provide a succinct answer. 1.01. What is the ratio of the Total Labor Force (in %) of Arab World in 1994 to that in 1997?
Provide a short and direct response. 1.01. What is the ratio of the Total Labor Force (in %) in Arab World in 1994 to that in 1998?
Your answer should be compact. 1.02. What is the ratio of the Total Labor Force (in %) in Czech Republic in 1994 to that in 1998?
Your response must be concise. 1. What is the ratio of the Total Labor Force (in %) in Sudan in 1994 to that in 1998?
Make the answer very short. 1. What is the ratio of the Total Labor Force (in %) in Arab World in 1994 to that in 1999?
Offer a terse response. 1.01. What is the ratio of the Total Labor Force (in %) in Czech Republic in 1994 to that in 1999?
Offer a very short reply. 1. What is the ratio of the Total Labor Force (in %) in Somalia in 1994 to that in 1999?
Make the answer very short. 1.01. What is the ratio of the Total Labor Force (in %) in Arab World in 1994 to that in 2000?
Your answer should be compact. 1.01. What is the ratio of the Total Labor Force (in %) of Czech Republic in 1994 to that in 2000?
Offer a terse response. 1.01. What is the ratio of the Total Labor Force (in %) of Somalia in 1994 to that in 2000?
Keep it short and to the point. 1.01. What is the ratio of the Total Labor Force (in %) in Czech Republic in 1995 to that in 1996?
Keep it short and to the point. 1. What is the ratio of the Total Labor Force (in %) in Sudan in 1995 to that in 1996?
Keep it short and to the point. 1.01. What is the ratio of the Total Labor Force (in %) of Arab World in 1995 to that in 1997?
Offer a terse response. 1.01. What is the ratio of the Total Labor Force (in %) in Czech Republic in 1995 to that in 1997?
Keep it short and to the point. 1. What is the ratio of the Total Labor Force (in %) in Somalia in 1995 to that in 1997?
Your answer should be very brief. 1. What is the ratio of the Total Labor Force (in %) of Sudan in 1995 to that in 1997?
Provide a short and direct response. 1. What is the ratio of the Total Labor Force (in %) in Arab World in 1995 to that in 1998?
Give a very brief answer. 1.01. What is the ratio of the Total Labor Force (in %) in Somalia in 1995 to that in 1998?
Your answer should be very brief. 1. What is the ratio of the Total Labor Force (in %) in Arab World in 1995 to that in 1999?
Keep it short and to the point. 1.01. What is the ratio of the Total Labor Force (in %) in Czech Republic in 1995 to that in 1999?
Ensure brevity in your answer.  1. What is the ratio of the Total Labor Force (in %) of Arab World in 1995 to that in 2000?
Give a very brief answer. 1.01. What is the ratio of the Total Labor Force (in %) of Czech Republic in 1995 to that in 2000?
Offer a terse response. 1.01. What is the ratio of the Total Labor Force (in %) in Somalia in 1995 to that in 2000?
Provide a short and direct response. 1.01. What is the ratio of the Total Labor Force (in %) in Sudan in 1995 to that in 2000?
Your response must be concise. 1. What is the ratio of the Total Labor Force (in %) of Arab World in 1996 to that in 1997?
Ensure brevity in your answer.  1. What is the ratio of the Total Labor Force (in %) in Somalia in 1996 to that in 1997?
Offer a very short reply. 1. What is the ratio of the Total Labor Force (in %) of Arab World in 1996 to that in 1998?
Offer a very short reply. 1.01. What is the ratio of the Total Labor Force (in %) of Czech Republic in 1996 to that in 1998?
Keep it short and to the point. 1. What is the ratio of the Total Labor Force (in %) in Somalia in 1996 to that in 1998?
Keep it short and to the point. 1. What is the ratio of the Total Labor Force (in %) in Arab World in 1996 to that in 1999?
Your answer should be very brief. 1.01. What is the ratio of the Total Labor Force (in %) of Czech Republic in 1996 to that in 1999?
Keep it short and to the point. 1. What is the ratio of the Total Labor Force (in %) of Somalia in 1996 to that in 1999?
Give a very brief answer. 1. What is the ratio of the Total Labor Force (in %) of Arab World in 1996 to that in 2000?
Offer a terse response. 1.01. What is the ratio of the Total Labor Force (in %) of Czech Republic in 1996 to that in 2000?
Give a very brief answer. 1.01. What is the ratio of the Total Labor Force (in %) of Arab World in 1997 to that in 1998?
Give a very brief answer. 1.01. What is the ratio of the Total Labor Force (in %) of Arab World in 1997 to that in 1999?
Offer a terse response. 1. What is the ratio of the Total Labor Force (in %) in Czech Republic in 1997 to that in 1999?
Your answer should be compact. 1. What is the ratio of the Total Labor Force (in %) of Somalia in 1997 to that in 1999?
Your response must be concise. 1. What is the ratio of the Total Labor Force (in %) of Arab World in 1997 to that in 2000?
Your answer should be compact. 1. What is the ratio of the Total Labor Force (in %) of Czech Republic in 1997 to that in 2000?
Make the answer very short. 1.01. What is the ratio of the Total Labor Force (in %) of Sudan in 1997 to that in 2000?
Your answer should be compact. 1. What is the ratio of the Total Labor Force (in %) in Arab World in 1998 to that in 1999?
Keep it short and to the point. 1. What is the ratio of the Total Labor Force (in %) of Czech Republic in 1998 to that in 1999?
Make the answer very short. 1. What is the ratio of the Total Labor Force (in %) of Sudan in 1998 to that in 1999?
Ensure brevity in your answer.  1. What is the ratio of the Total Labor Force (in %) in Arab World in 1998 to that in 2000?
Provide a short and direct response. 1. What is the ratio of the Total Labor Force (in %) of Czech Republic in 1998 to that in 2000?
Offer a very short reply. 1.01. What is the ratio of the Total Labor Force (in %) in Somalia in 1998 to that in 2000?
Offer a terse response. 1. What is the ratio of the Total Labor Force (in %) of Czech Republic in 1999 to that in 2000?
Make the answer very short. 1.01. What is the ratio of the Total Labor Force (in %) of Sudan in 1999 to that in 2000?
Make the answer very short. 1. What is the difference between the highest and the second highest Total Labor Force (in %) in Arab World?
Ensure brevity in your answer.  0.21. What is the difference between the highest and the second highest Total Labor Force (in %) of Somalia?
Your response must be concise. 0.1. What is the difference between the highest and the second highest Total Labor Force (in %) in Sudan?
Ensure brevity in your answer.  0. What is the difference between the highest and the lowest Total Labor Force (in %) in Arab World?
Your response must be concise. 1.18. What is the difference between the highest and the lowest Total Labor Force (in %) in Somalia?
Keep it short and to the point. 0.8. 